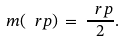Convert formula to latex. <formula><loc_0><loc_0><loc_500><loc_500>m ( \ r p ) \, = \, \frac { \ r p } { 2 } .</formula> 